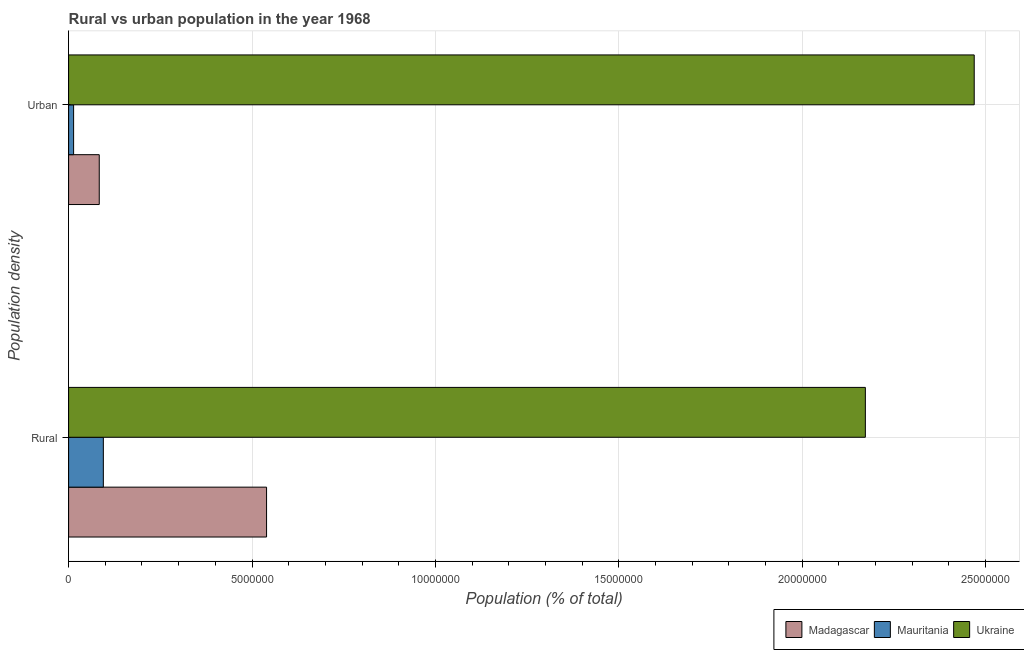How many different coloured bars are there?
Make the answer very short. 3. How many groups of bars are there?
Your answer should be compact. 2. Are the number of bars per tick equal to the number of legend labels?
Your response must be concise. Yes. Are the number of bars on each tick of the Y-axis equal?
Offer a terse response. Yes. What is the label of the 1st group of bars from the top?
Your answer should be very brief. Urban. What is the rural population density in Madagascar?
Your answer should be very brief. 5.40e+06. Across all countries, what is the maximum rural population density?
Ensure brevity in your answer.  2.17e+07. Across all countries, what is the minimum urban population density?
Provide a succinct answer. 1.37e+05. In which country was the urban population density maximum?
Your response must be concise. Ukraine. In which country was the rural population density minimum?
Give a very brief answer. Mauritania. What is the total rural population density in the graph?
Offer a very short reply. 2.81e+07. What is the difference between the rural population density in Mauritania and that in Madagascar?
Provide a short and direct response. -4.45e+06. What is the difference between the urban population density in Ukraine and the rural population density in Mauritania?
Your response must be concise. 2.37e+07. What is the average urban population density per country?
Your answer should be very brief. 8.55e+06. What is the difference between the urban population density and rural population density in Madagascar?
Keep it short and to the point. -4.56e+06. What is the ratio of the rural population density in Mauritania to that in Madagascar?
Make the answer very short. 0.18. What does the 3rd bar from the top in Urban represents?
Your response must be concise. Madagascar. What does the 2nd bar from the bottom in Rural represents?
Provide a short and direct response. Mauritania. Are all the bars in the graph horizontal?
Your response must be concise. Yes. How many legend labels are there?
Give a very brief answer. 3. How are the legend labels stacked?
Ensure brevity in your answer.  Horizontal. What is the title of the graph?
Provide a short and direct response. Rural vs urban population in the year 1968. What is the label or title of the X-axis?
Offer a terse response. Population (% of total). What is the label or title of the Y-axis?
Your answer should be compact. Population density. What is the Population (% of total) of Madagascar in Rural?
Your answer should be very brief. 5.40e+06. What is the Population (% of total) of Mauritania in Rural?
Your answer should be compact. 9.47e+05. What is the Population (% of total) in Ukraine in Rural?
Offer a terse response. 2.17e+07. What is the Population (% of total) in Madagascar in Urban?
Offer a very short reply. 8.36e+05. What is the Population (% of total) in Mauritania in Urban?
Provide a succinct answer. 1.37e+05. What is the Population (% of total) of Ukraine in Urban?
Provide a succinct answer. 2.47e+07. Across all Population density, what is the maximum Population (% of total) in Madagascar?
Your answer should be very brief. 5.40e+06. Across all Population density, what is the maximum Population (% of total) of Mauritania?
Provide a short and direct response. 9.47e+05. Across all Population density, what is the maximum Population (% of total) of Ukraine?
Make the answer very short. 2.47e+07. Across all Population density, what is the minimum Population (% of total) in Madagascar?
Your answer should be very brief. 8.36e+05. Across all Population density, what is the minimum Population (% of total) in Mauritania?
Ensure brevity in your answer.  1.37e+05. Across all Population density, what is the minimum Population (% of total) of Ukraine?
Provide a short and direct response. 2.17e+07. What is the total Population (% of total) of Madagascar in the graph?
Make the answer very short. 6.23e+06. What is the total Population (% of total) of Mauritania in the graph?
Your response must be concise. 1.08e+06. What is the total Population (% of total) in Ukraine in the graph?
Keep it short and to the point. 4.64e+07. What is the difference between the Population (% of total) in Madagascar in Rural and that in Urban?
Offer a terse response. 4.56e+06. What is the difference between the Population (% of total) in Mauritania in Rural and that in Urban?
Your response must be concise. 8.10e+05. What is the difference between the Population (% of total) in Ukraine in Rural and that in Urban?
Ensure brevity in your answer.  -2.97e+06. What is the difference between the Population (% of total) in Madagascar in Rural and the Population (% of total) in Mauritania in Urban?
Offer a terse response. 5.26e+06. What is the difference between the Population (% of total) in Madagascar in Rural and the Population (% of total) in Ukraine in Urban?
Your answer should be very brief. -1.93e+07. What is the difference between the Population (% of total) in Mauritania in Rural and the Population (% of total) in Ukraine in Urban?
Give a very brief answer. -2.37e+07. What is the average Population (% of total) in Madagascar per Population density?
Offer a terse response. 3.12e+06. What is the average Population (% of total) in Mauritania per Population density?
Your response must be concise. 5.42e+05. What is the average Population (% of total) in Ukraine per Population density?
Keep it short and to the point. 2.32e+07. What is the difference between the Population (% of total) in Madagascar and Population (% of total) in Mauritania in Rural?
Offer a very short reply. 4.45e+06. What is the difference between the Population (% of total) of Madagascar and Population (% of total) of Ukraine in Rural?
Your response must be concise. -1.63e+07. What is the difference between the Population (% of total) of Mauritania and Population (% of total) of Ukraine in Rural?
Your answer should be very brief. -2.08e+07. What is the difference between the Population (% of total) of Madagascar and Population (% of total) of Mauritania in Urban?
Ensure brevity in your answer.  6.99e+05. What is the difference between the Population (% of total) in Madagascar and Population (% of total) in Ukraine in Urban?
Your answer should be compact. -2.39e+07. What is the difference between the Population (% of total) in Mauritania and Population (% of total) in Ukraine in Urban?
Make the answer very short. -2.46e+07. What is the ratio of the Population (% of total) in Madagascar in Rural to that in Urban?
Offer a very short reply. 6.46. What is the ratio of the Population (% of total) of Mauritania in Rural to that in Urban?
Make the answer very short. 6.93. What is the ratio of the Population (% of total) of Ukraine in Rural to that in Urban?
Provide a short and direct response. 0.88. What is the difference between the highest and the second highest Population (% of total) of Madagascar?
Offer a terse response. 4.56e+06. What is the difference between the highest and the second highest Population (% of total) in Mauritania?
Ensure brevity in your answer.  8.10e+05. What is the difference between the highest and the second highest Population (% of total) of Ukraine?
Provide a succinct answer. 2.97e+06. What is the difference between the highest and the lowest Population (% of total) in Madagascar?
Your answer should be compact. 4.56e+06. What is the difference between the highest and the lowest Population (% of total) of Mauritania?
Provide a short and direct response. 8.10e+05. What is the difference between the highest and the lowest Population (% of total) of Ukraine?
Offer a terse response. 2.97e+06. 